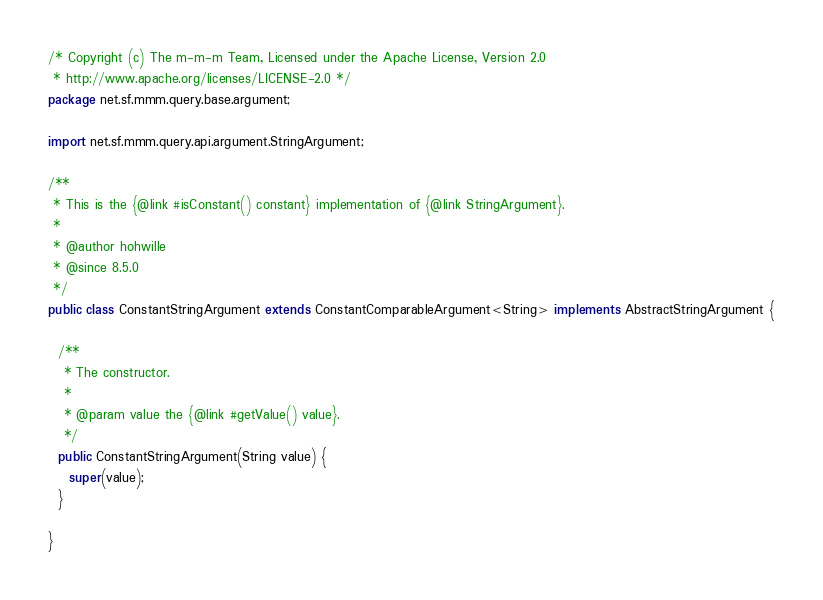Convert code to text. <code><loc_0><loc_0><loc_500><loc_500><_Java_>/* Copyright (c) The m-m-m Team, Licensed under the Apache License, Version 2.0
 * http://www.apache.org/licenses/LICENSE-2.0 */
package net.sf.mmm.query.base.argument;

import net.sf.mmm.query.api.argument.StringArgument;

/**
 * This is the {@link #isConstant() constant} implementation of {@link StringArgument}.
 *
 * @author hohwille
 * @since 8.5.0
 */
public class ConstantStringArgument extends ConstantComparableArgument<String> implements AbstractStringArgument {

  /**
   * The constructor.
   *
   * @param value the {@link #getValue() value}.
   */
  public ConstantStringArgument(String value) {
    super(value);
  }

}
</code> 